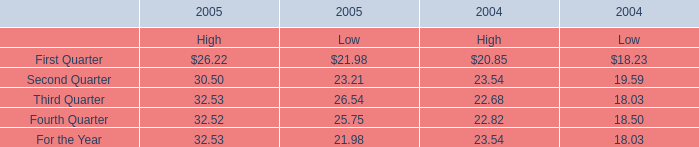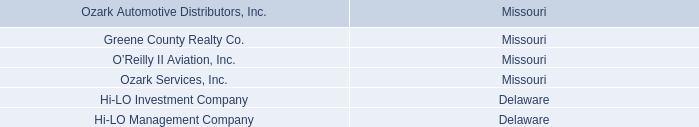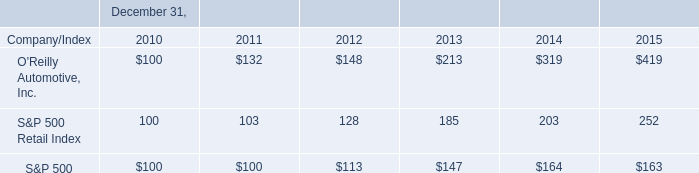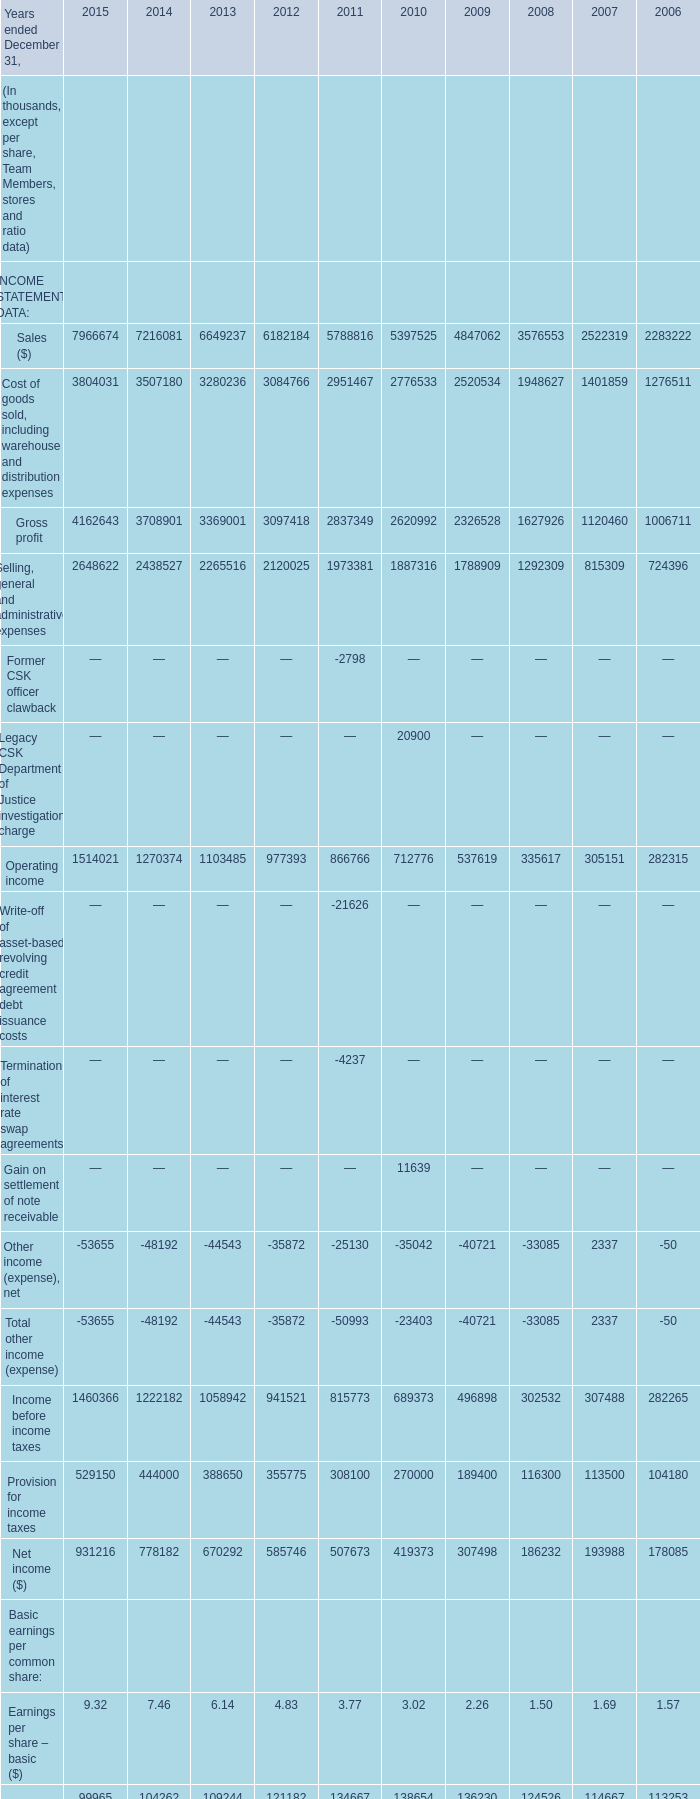What's the current growth rate of Earnings per share – basic ($)? 
Computations: ((9.32 - 7.46) / 9.32)
Answer: 0.19957. 